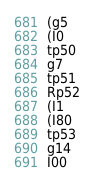Convert code to text. <code><loc_0><loc_0><loc_500><loc_500><_SQL_>(g5
(I0
tp50
g7
tp51
Rp52
(I1
(I80
tp53
g14
I00</code> 